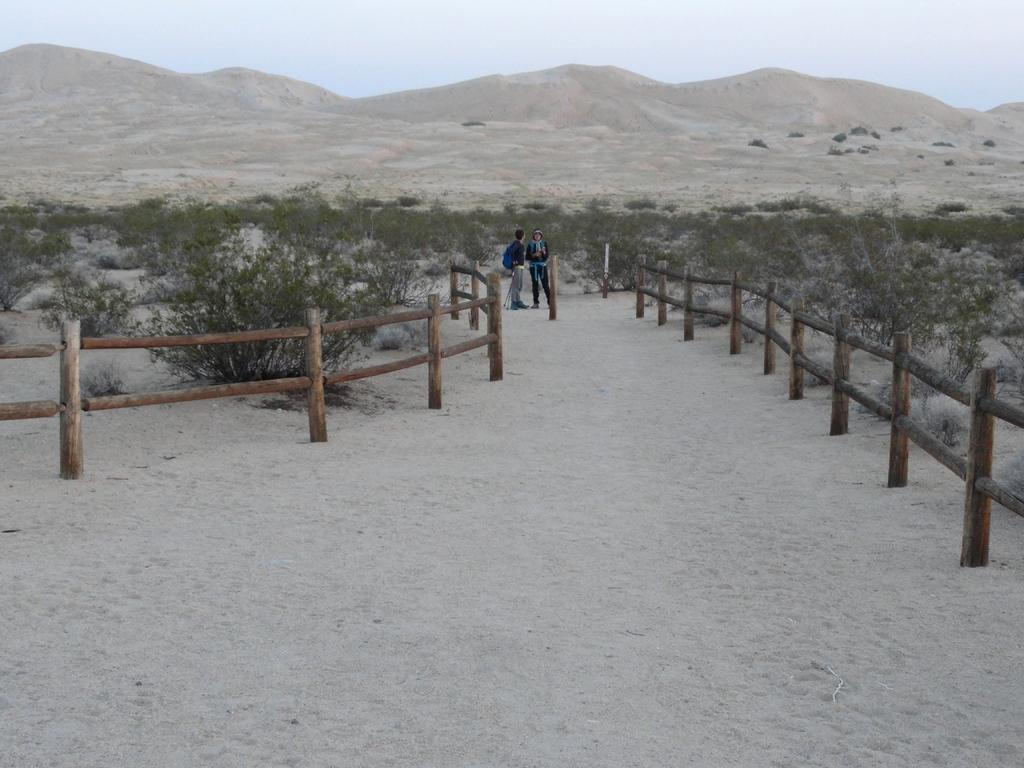Where was the image taken? The image was clicked outside. What can be seen in the middle of the image? There are bushes and two persons standing in the middle of the image. What is visible at the top of the image? Hills and the sky are visible at the top of the image. What type of friction can be observed between the wren and the form in the image? There is no wren or form present in the image, so no friction can be observed between them. 